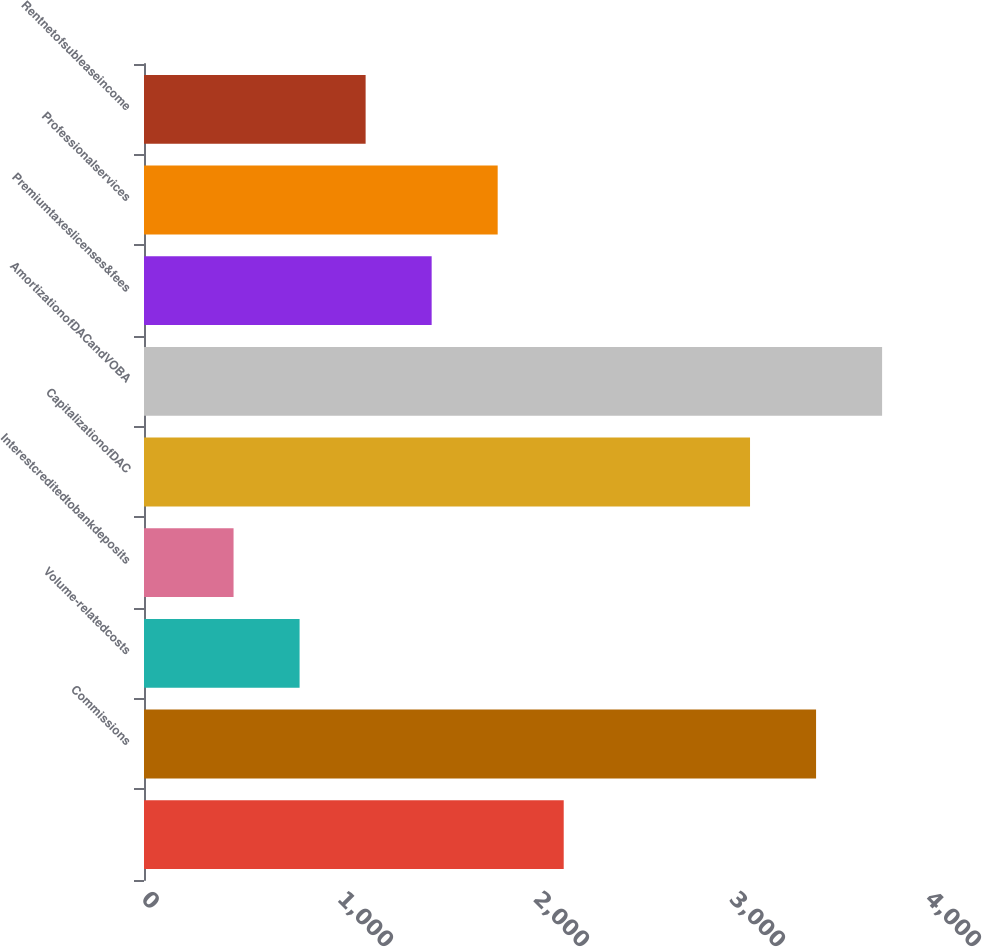Convert chart to OTSL. <chart><loc_0><loc_0><loc_500><loc_500><bar_chart><ecel><fcel>Commissions<fcel>Volume-relatedcosts<fcel>Interestcreditedtobankdeposits<fcel>CapitalizationofDAC<fcel>AmortizationofDACandVOBA<fcel>Premiumtaxeslicenses&fees<fcel>Professionalservices<fcel>Rentnetofsubleaseincome<nl><fcel>2141.4<fcel>3428.9<fcel>793.8<fcel>456.9<fcel>3092<fcel>3765.8<fcel>1467.6<fcel>1804.5<fcel>1130.7<nl></chart> 